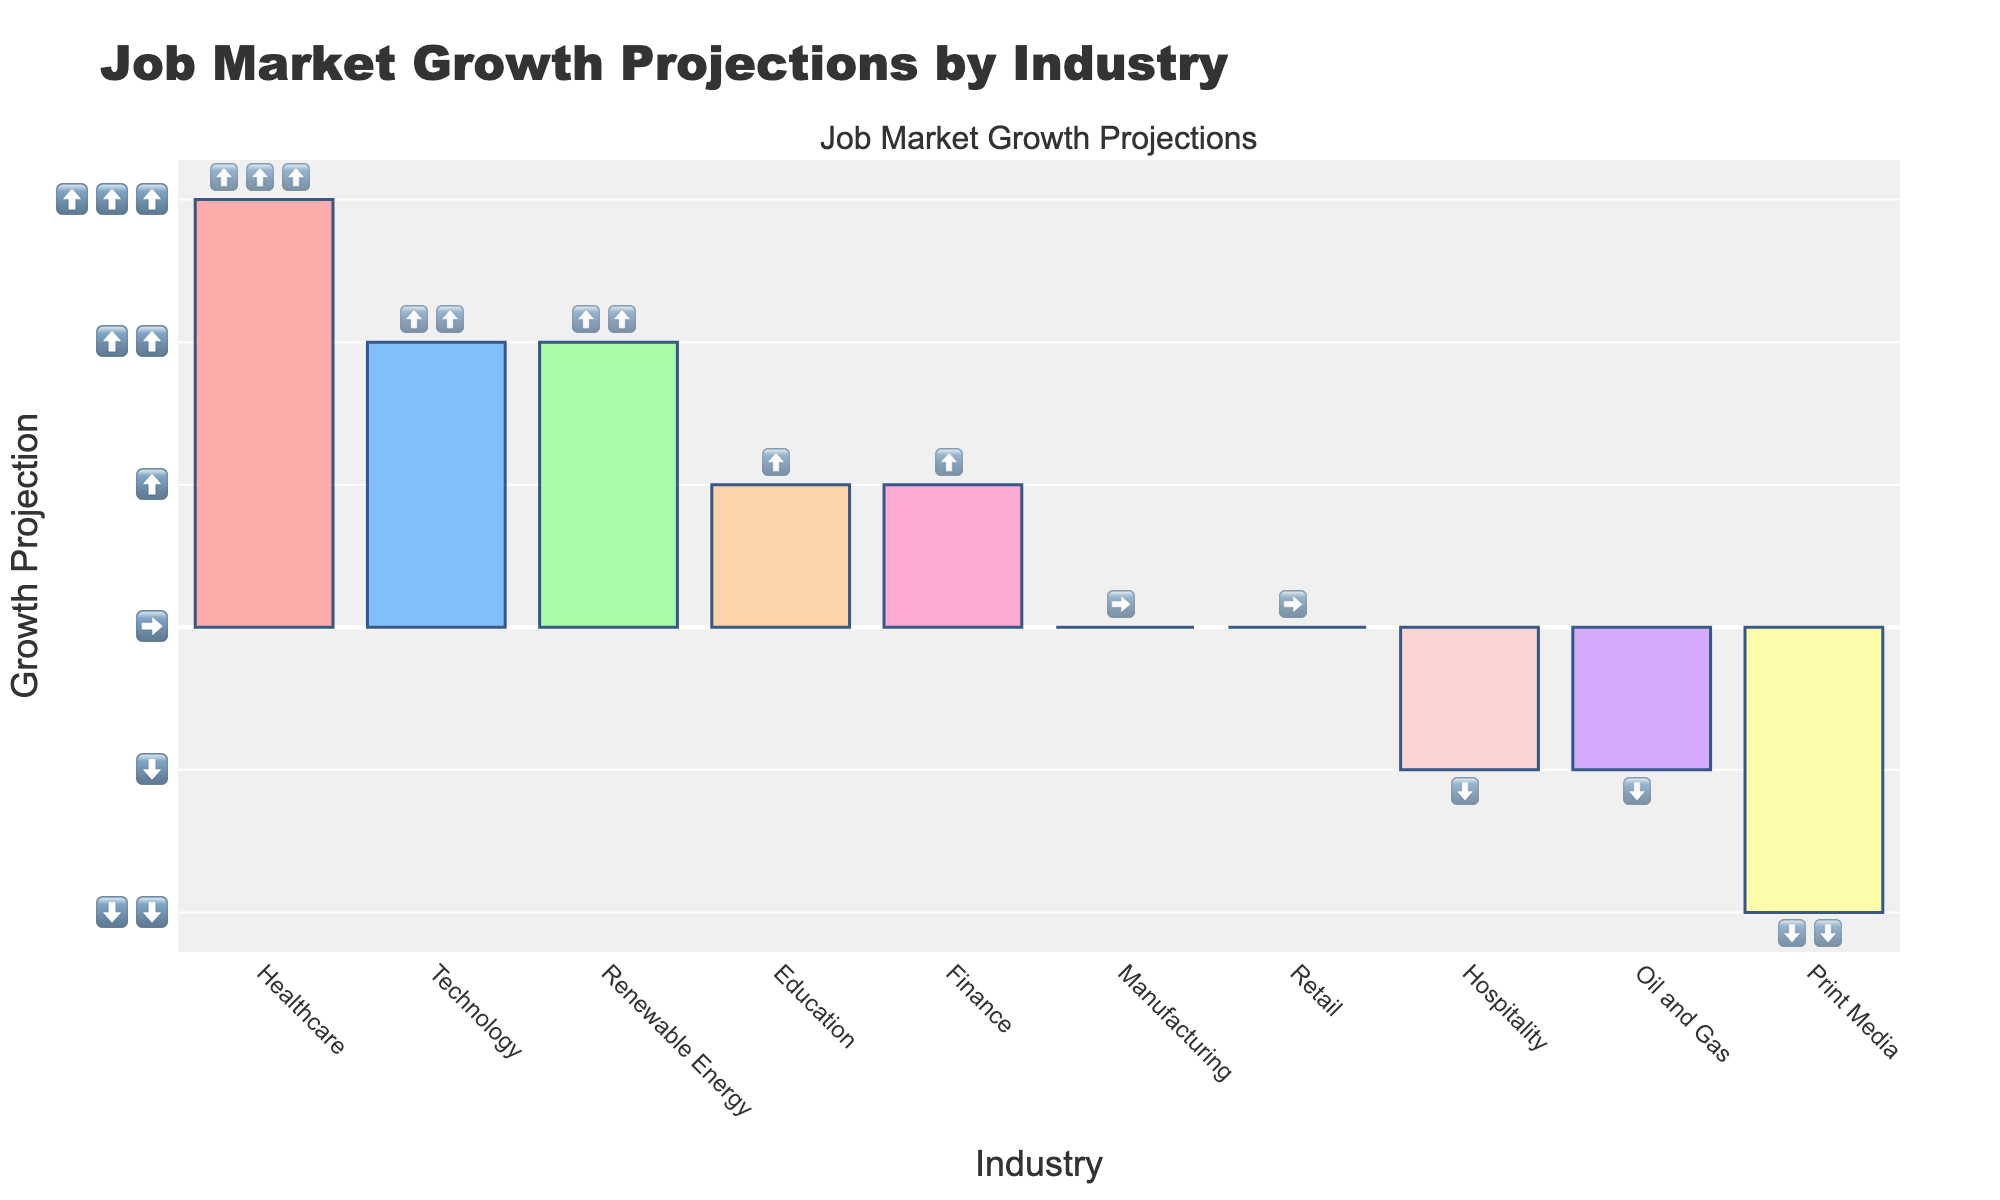what is the title of the figure? The title can be found at the top of the figure. It summarizes the main subject of the graph.
Answer: Job Market Growth Projections by Industry how many industries have a growth projection of stable or no change? Count the number of industries that are represented by the "➡️" emoji on the figure. This indicates no change in job market growth projections.
Answer: 2 which industry has the highest job market growth projection? Look for the industry with the most upward arrows (⬆️⬆️⬆️). This represents the highest growth projection.
Answer: Healthcare which industries have a job market growth projection of ⬆️⬆️? Identify the industries that have two upward arrows (⬆️⬆️), indicating a significant growth projection.
Answer: Technology, Renewable Energy which industry has the lowest job market growth projection? Find the industry represented by the "⬇️⬇️" emoji, which indicates the lowest growth projection.
Answer: Print Media how many more industries have a positive growth projection than a negative growth projection? First, count the industries with ⬆️⬆️⬆️, ⬆️⬆️, and ⬆️ emojis. Then, count the industries with ⬇️⬇️ and ⬇️ emojis. Subtract the number of negative industries from the number of positive industries.
Answer: 3 what is the total number of industries with job market growth projections of ⬆️ or higher? Count all the industries that have at least one upward arrow (⬆️). These are the industries with some positive growth projection.
Answer: 5 which industries have a job market growth projection worse than stable but not the worst? Look for industries represented by the "⬇️" emoji, which indicates a decline but not the worst decline.
Answer: Hospitality, Oil and Gas 